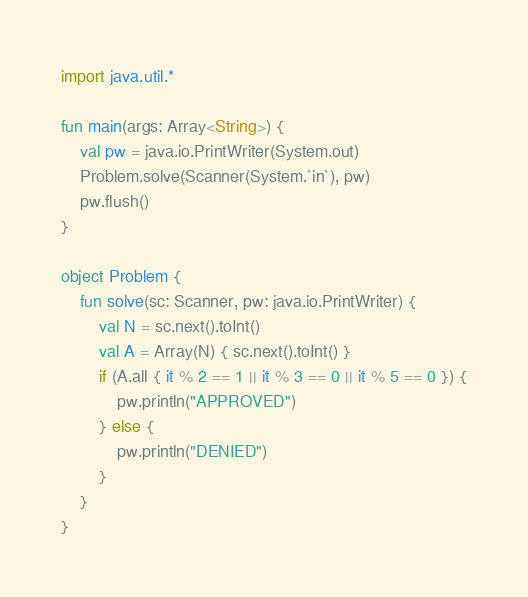Convert code to text. <code><loc_0><loc_0><loc_500><loc_500><_Kotlin_>import java.util.*

fun main(args: Array<String>) {
    val pw = java.io.PrintWriter(System.out)
    Problem.solve(Scanner(System.`in`), pw)
    pw.flush()
}

object Problem {
    fun solve(sc: Scanner, pw: java.io.PrintWriter) {
        val N = sc.next().toInt()
        val A = Array(N) { sc.next().toInt() }
        if (A.all { it % 2 == 1 || it % 3 == 0 || it % 5 == 0 }) {
            pw.println("APPROVED")
        } else {
            pw.println("DENIED")
        }
    }
}
</code> 